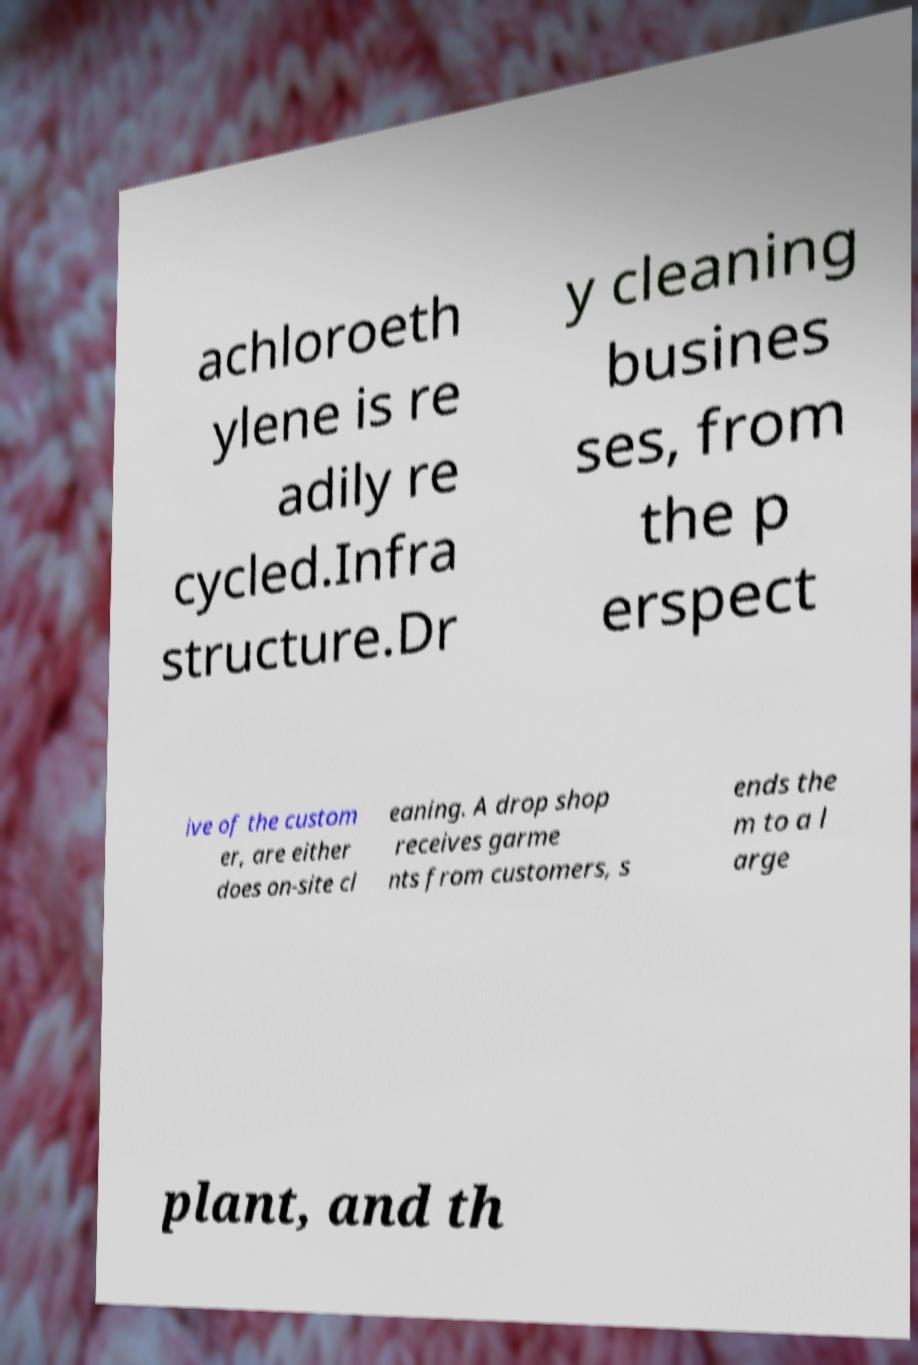Could you assist in decoding the text presented in this image and type it out clearly? achloroeth ylene is re adily re cycled.Infra structure.Dr y cleaning busines ses, from the p erspect ive of the custom er, are either does on-site cl eaning. A drop shop receives garme nts from customers, s ends the m to a l arge plant, and th 